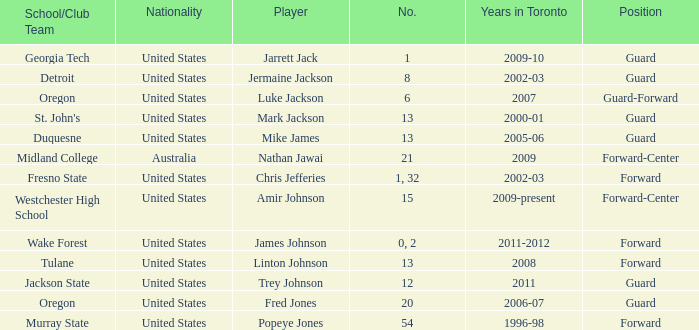Give me the full table as a dictionary. {'header': ['School/Club Team', 'Nationality', 'Player', 'No.', 'Years in Toronto', 'Position'], 'rows': [['Georgia Tech', 'United States', 'Jarrett Jack', '1', '2009-10', 'Guard'], ['Detroit', 'United States', 'Jermaine Jackson', '8', '2002-03', 'Guard'], ['Oregon', 'United States', 'Luke Jackson', '6', '2007', 'Guard-Forward'], ["St. John's", 'United States', 'Mark Jackson', '13', '2000-01', 'Guard'], ['Duquesne', 'United States', 'Mike James', '13', '2005-06', 'Guard'], ['Midland College', 'Australia', 'Nathan Jawai', '21', '2009', 'Forward-Center'], ['Fresno State', 'United States', 'Chris Jefferies', '1, 32', '2002-03', 'Forward'], ['Westchester High School', 'United States', 'Amir Johnson', '15', '2009-present', 'Forward-Center'], ['Wake Forest', 'United States', 'James Johnson', '0, 2', '2011-2012', 'Forward'], ['Tulane', 'United States', 'Linton Johnson', '13', '2008', 'Forward'], ['Jackson State', 'United States', 'Trey Johnson', '12', '2011', 'Guard'], ['Oregon', 'United States', 'Fred Jones', '20', '2006-07', 'Guard'], ['Murray State', 'United States', 'Popeye Jones', '54', '1996-98', 'Forward']]} What are the total number of positions on the Toronto team in 2006-07? 1.0. 